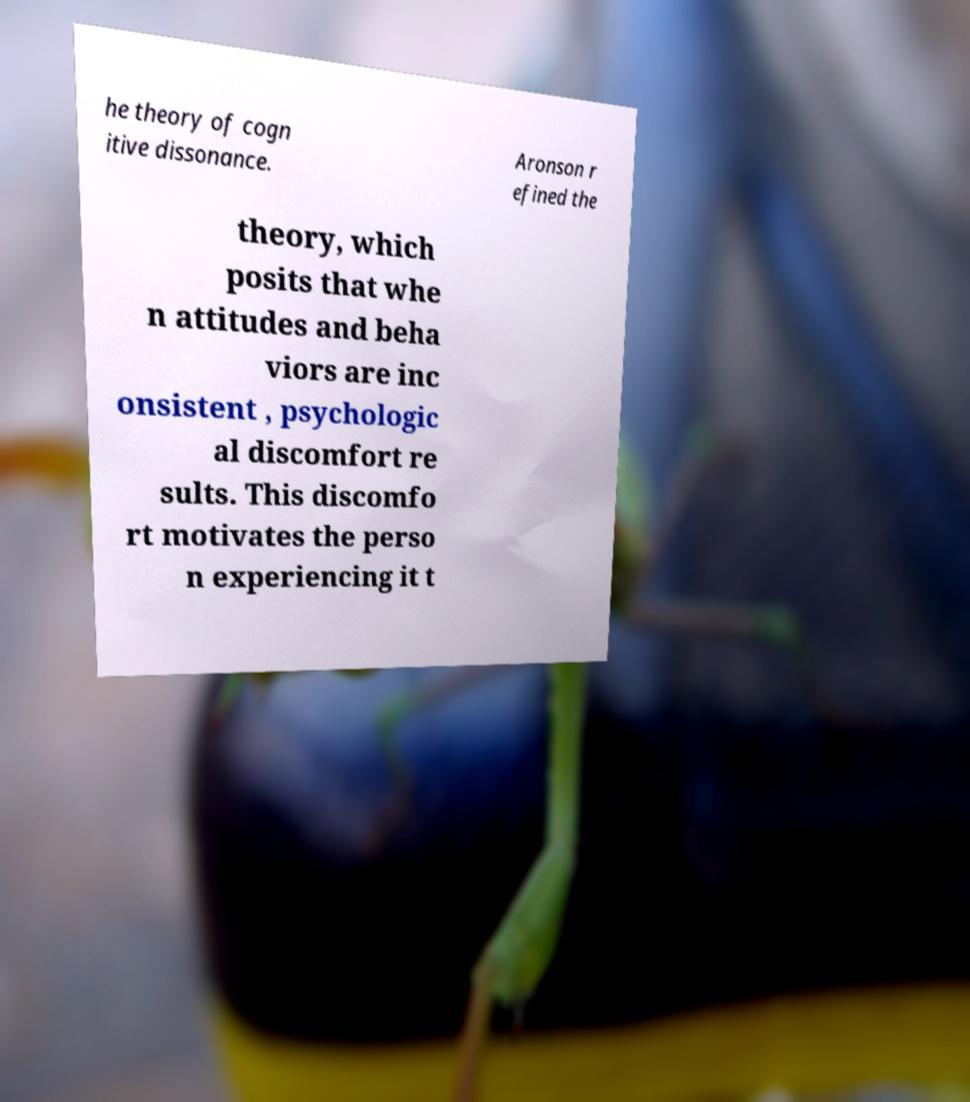I need the written content from this picture converted into text. Can you do that? he theory of cogn itive dissonance. Aronson r efined the theory, which posits that whe n attitudes and beha viors are inc onsistent , psychologic al discomfort re sults. This discomfo rt motivates the perso n experiencing it t 